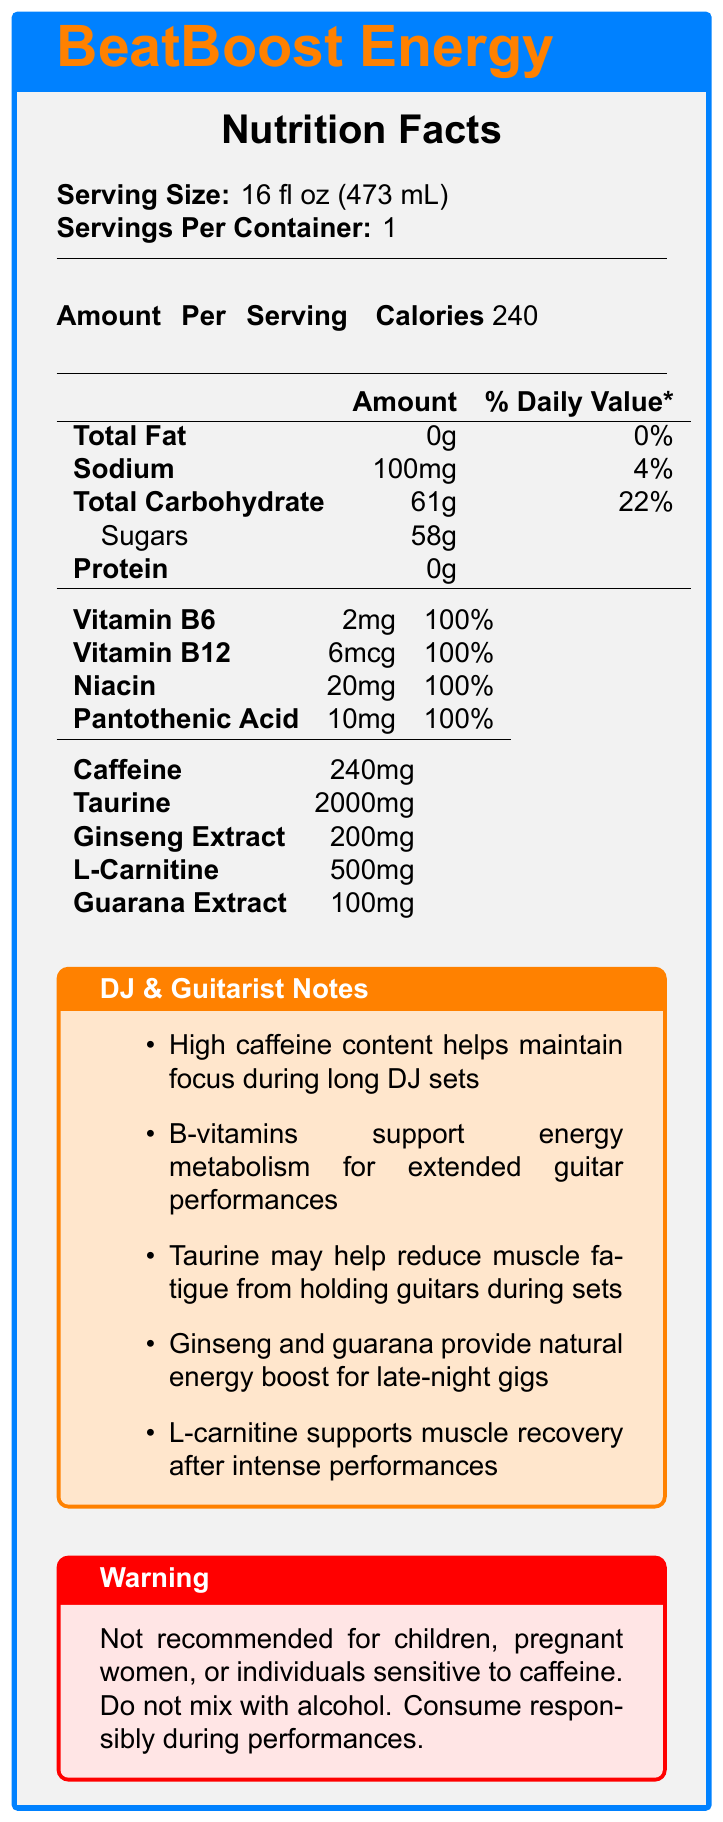what is the serving size for BeatBoost Energy? According to the document, the serving size for BeatBoost Energy is 16 fl oz (473 mL).
Answer: 16 fl oz (473 mL) how many calories are in one serving of BeatBoost Energy? The document states that there are 240 calories per serving.
Answer: 240 what is the amount of sodium in BeatBoost Energy? The document lists sodium as 100mg per serving.
Answer: 100mg what percentage of the daily value of carbohydrates does BeatBoost Energy provide? The document indicates that the total carbohydrate content is 22% of the daily value.
Answer: 22% how much caffeine is in a serving of BeatBoost Energy? The document shows that there is 240mg of caffeine per serving.
Answer: 240mg which of the following vitamins are present in BeatBoost Energy? A. Vitamin C B. Vitamin D C. Vitamin B6 D. Vitamin B2 The document lists Vitamin B6 as one of the vitamins included in BeatBoost Energy.
Answer: C. Vitamin B6 what is the amount of taurine per serving in BeatBoost Energy? A. 200mg B. 100mg C. 2000mg D. 500mg The document specifies that there is 2000mg of taurine per serving.
Answer: C. 2000mg is BeatBoost Energy recommended for children and pregnant women? The warning section in the document explicitly states that it is not recommended for children or pregnant women.
Answer: No describe the main idea of the document. The document provides detailed nutritional information, beneficial notes for DJs and guitarists, and a cautionary warning.
Answer: The document is a nutrition facts label for BeatBoost Energy, detailing its serving size, calorie content, nutritional information, and ingredients. The label includes specific notes for DJs and guitarists, highlighting the benefits such as maintaining focus and muscle recovery, and provides a warning for certain individuals. does BeatBoost Energy contain any fat? The document shows that the total fat content is 0g, which means it contains no fat.
Answer: No how much protein is in BeatBoost Energy? The document indicates that there is 0g of protein per serving.
Answer: 0g which vitamin in BeatBoost Energy is listed in micrograms (mcg)? The document lists Vitamin B12 amount as 6mcg.
Answer: Vitamin B12 what is the primary benefit of taurine for guitarists according to the notes? The document notes that taurine may help reduce muscle fatigue from holding guitars during sets.
Answer: May help reduce muscle fatigue what is the total amount of vitamins and minerals listed in BeatBoost Energy? The document lists four vitamins and minerals: Vitamin B6, Vitamin B12, Niacin, and Pantothenic Acid.
Answer: 4 how much sugar does BeatBoost Energy contain? The document states that there are 58g of sugars in BeatBoost Energy.
Answer: 58g how much ginseng extract is in one serving of BeatBoost Energy? The document lists 200mg of ginseng extract per serving.
Answer: 200mg can the information on the caffeine sensitivity be found based on the visual document? The document does state a warning, but specific details regarding individual sensitivity to caffeine require additional medical advice and cannot be determined from the document alone.
Answer: No 